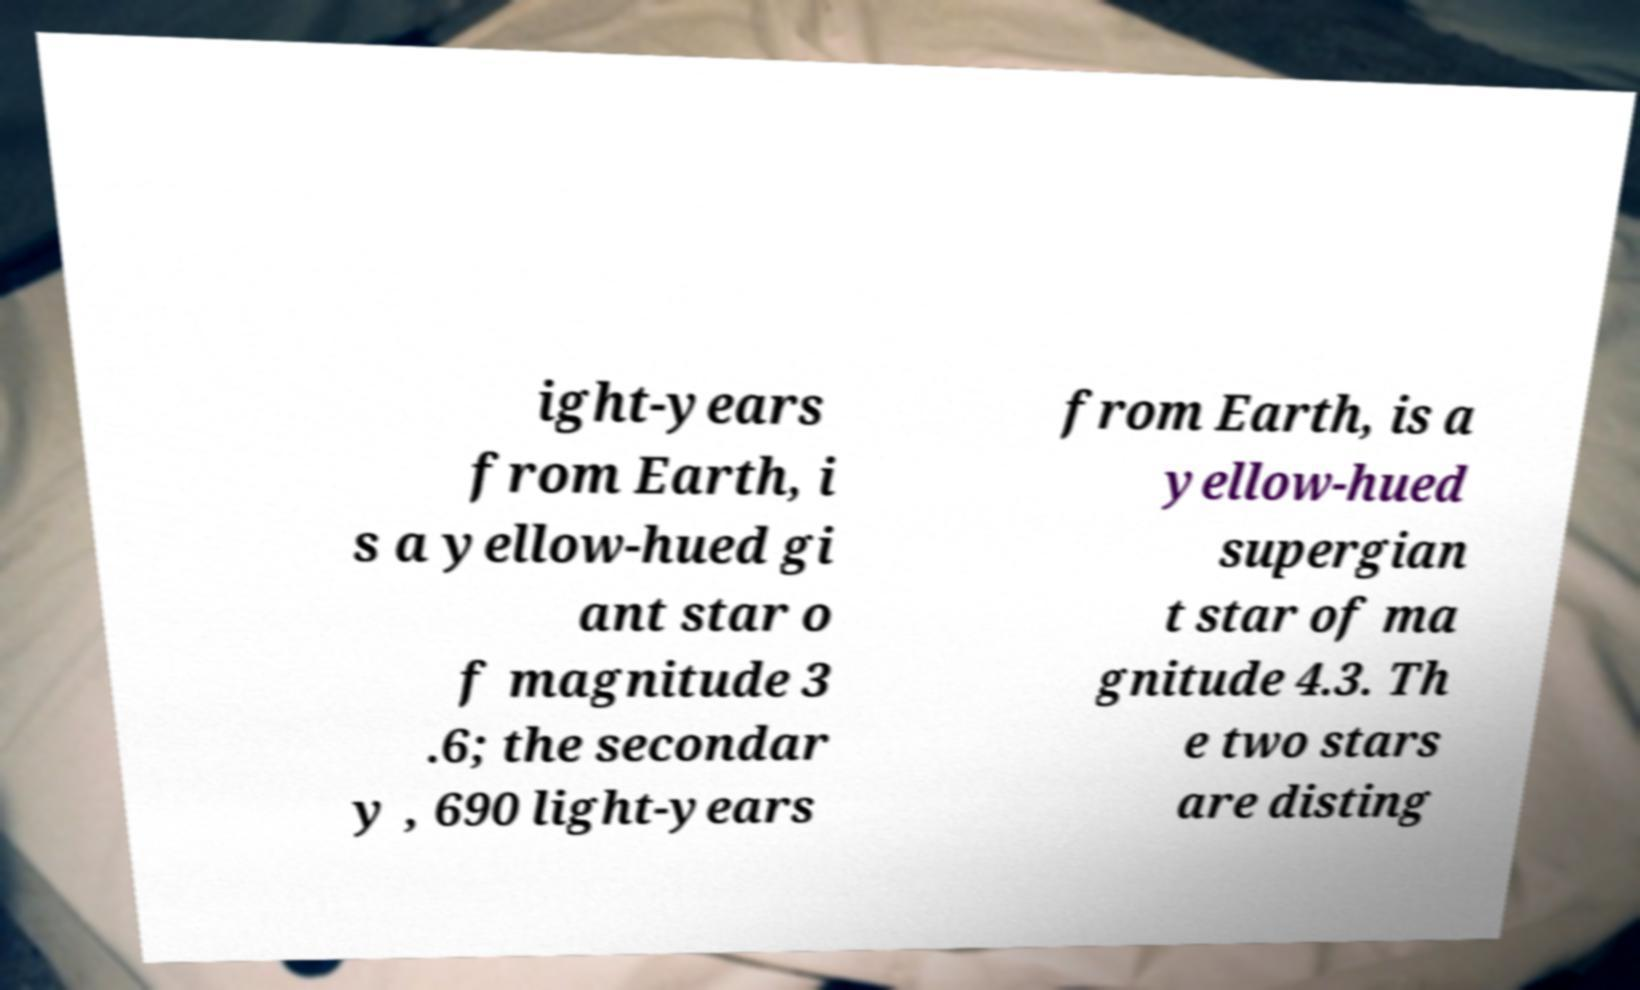Could you extract and type out the text from this image? ight-years from Earth, i s a yellow-hued gi ant star o f magnitude 3 .6; the secondar y , 690 light-years from Earth, is a yellow-hued supergian t star of ma gnitude 4.3. Th e two stars are disting 